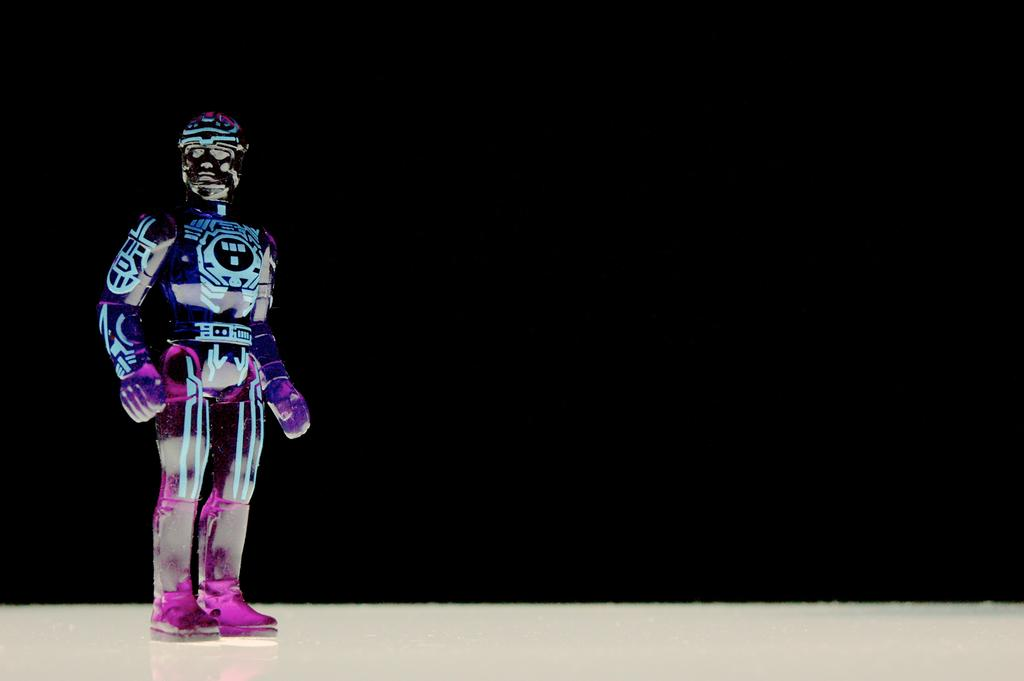What is the main subject of the image? There is a figurine in the image. Where is the figurine located? The figurine is on a platform. What color is the background of the image? The background of the image is black in color. Can you see any waves in the image? There are no waves present in the image; it features a figurine on a platform with a black background. Is there a bat flying in the image? There is no bat present in the image. 